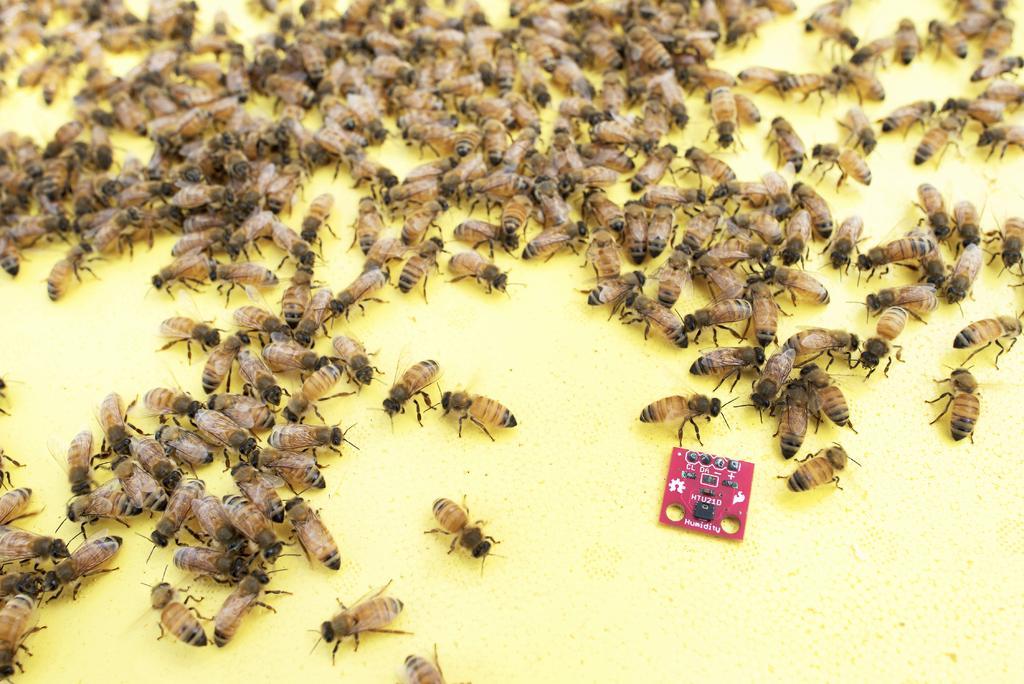Please provide a concise description of this image. In this picture there are many honey bee sitting on the yellow color food. 